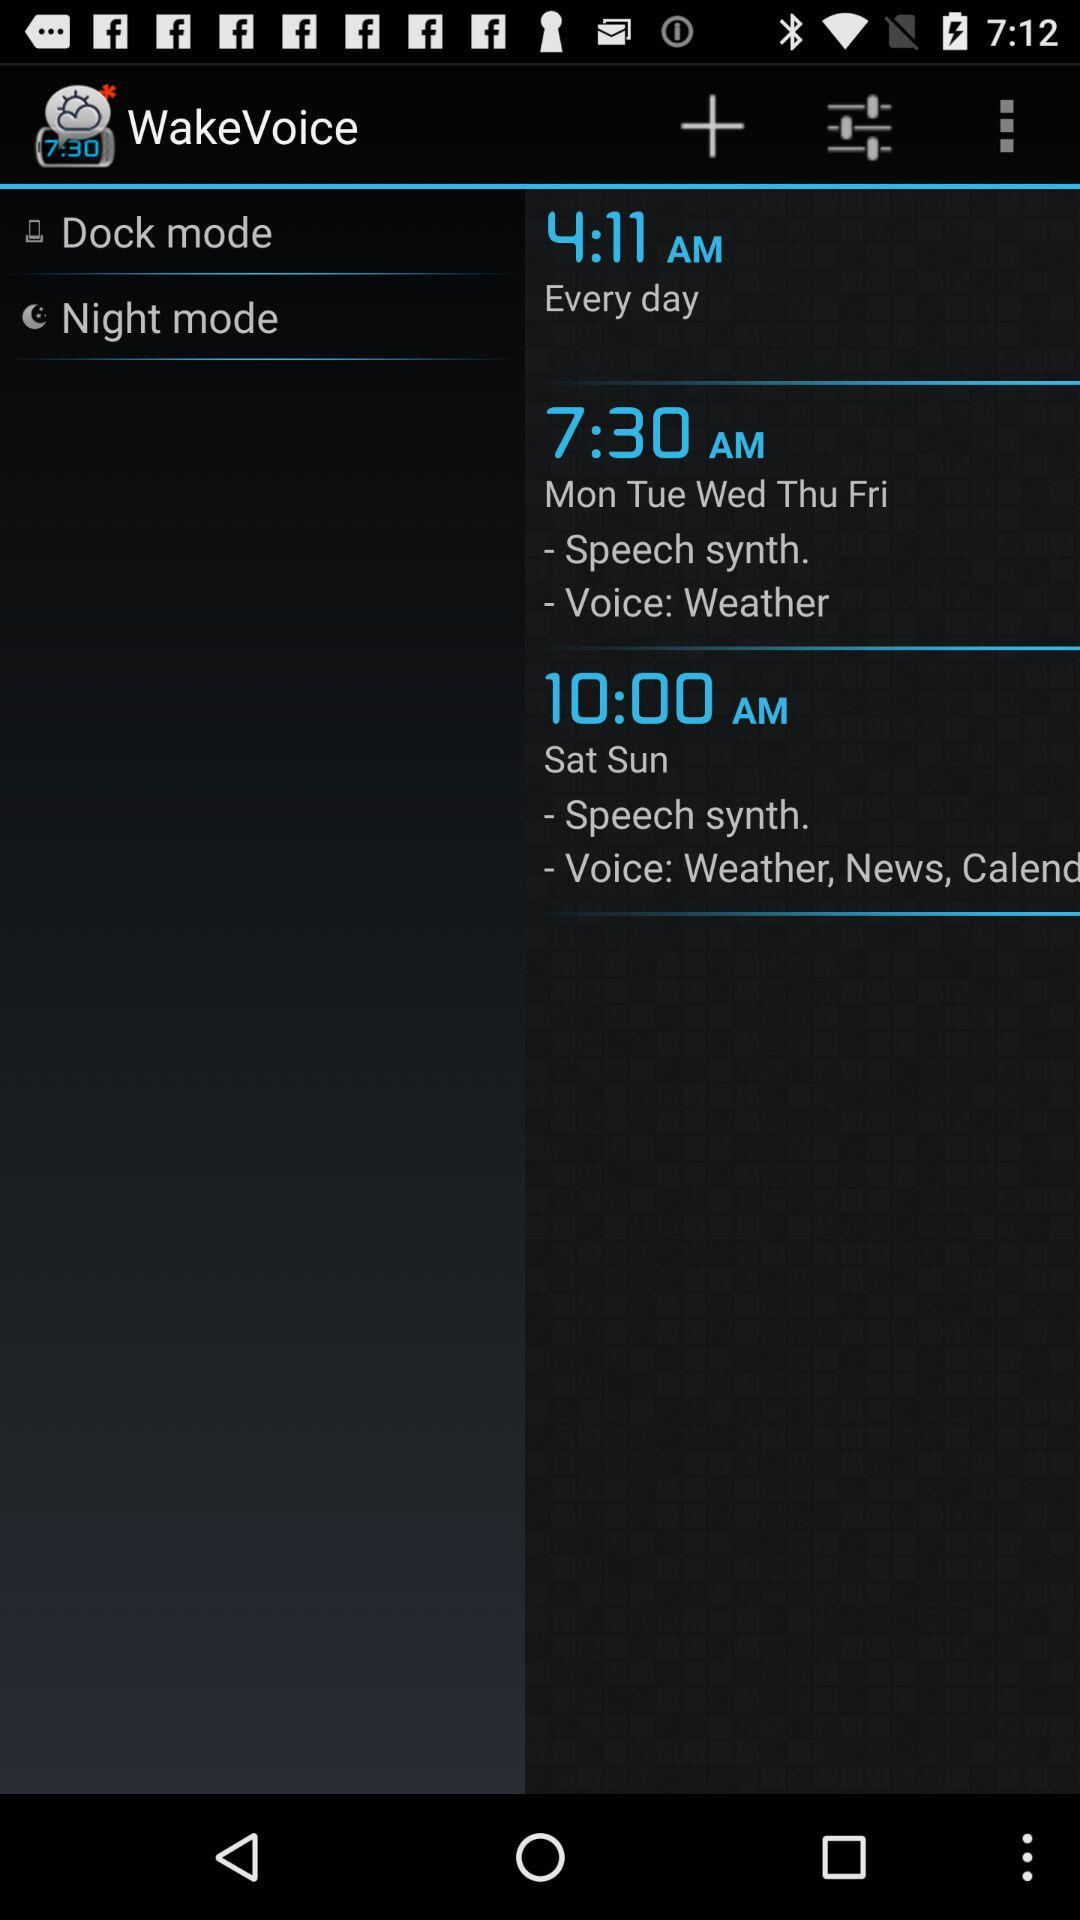How many days are there in the first alarm?
Answer the question using a single word or phrase. Every day 